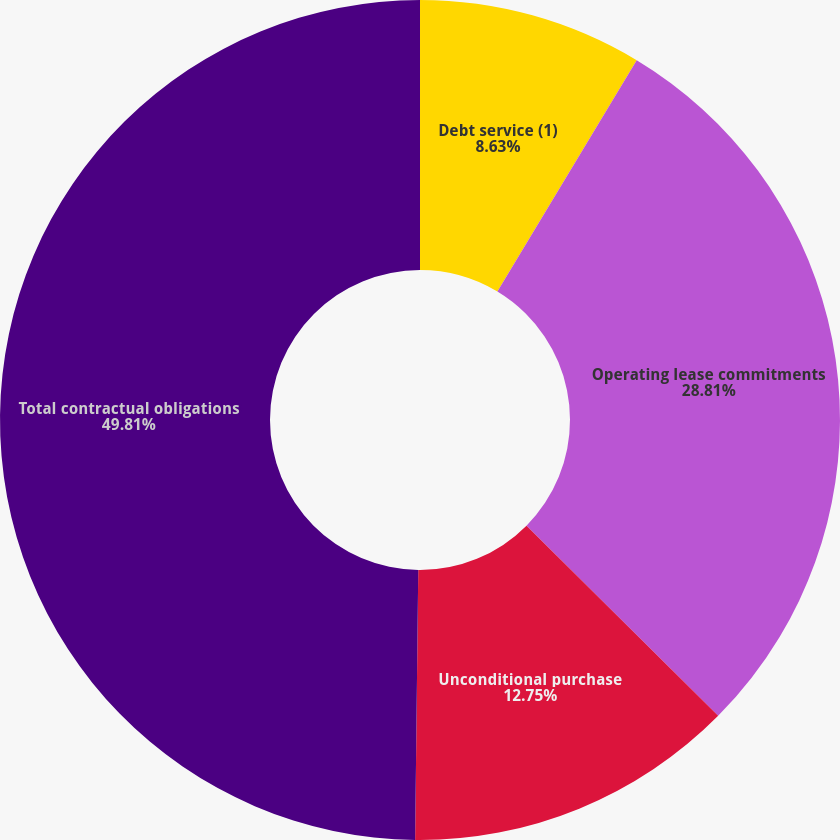Convert chart. <chart><loc_0><loc_0><loc_500><loc_500><pie_chart><fcel>Debt service (1)<fcel>Operating lease commitments<fcel>Unconditional purchase<fcel>Total contractual obligations<nl><fcel>8.63%<fcel>28.81%<fcel>12.75%<fcel>49.82%<nl></chart> 